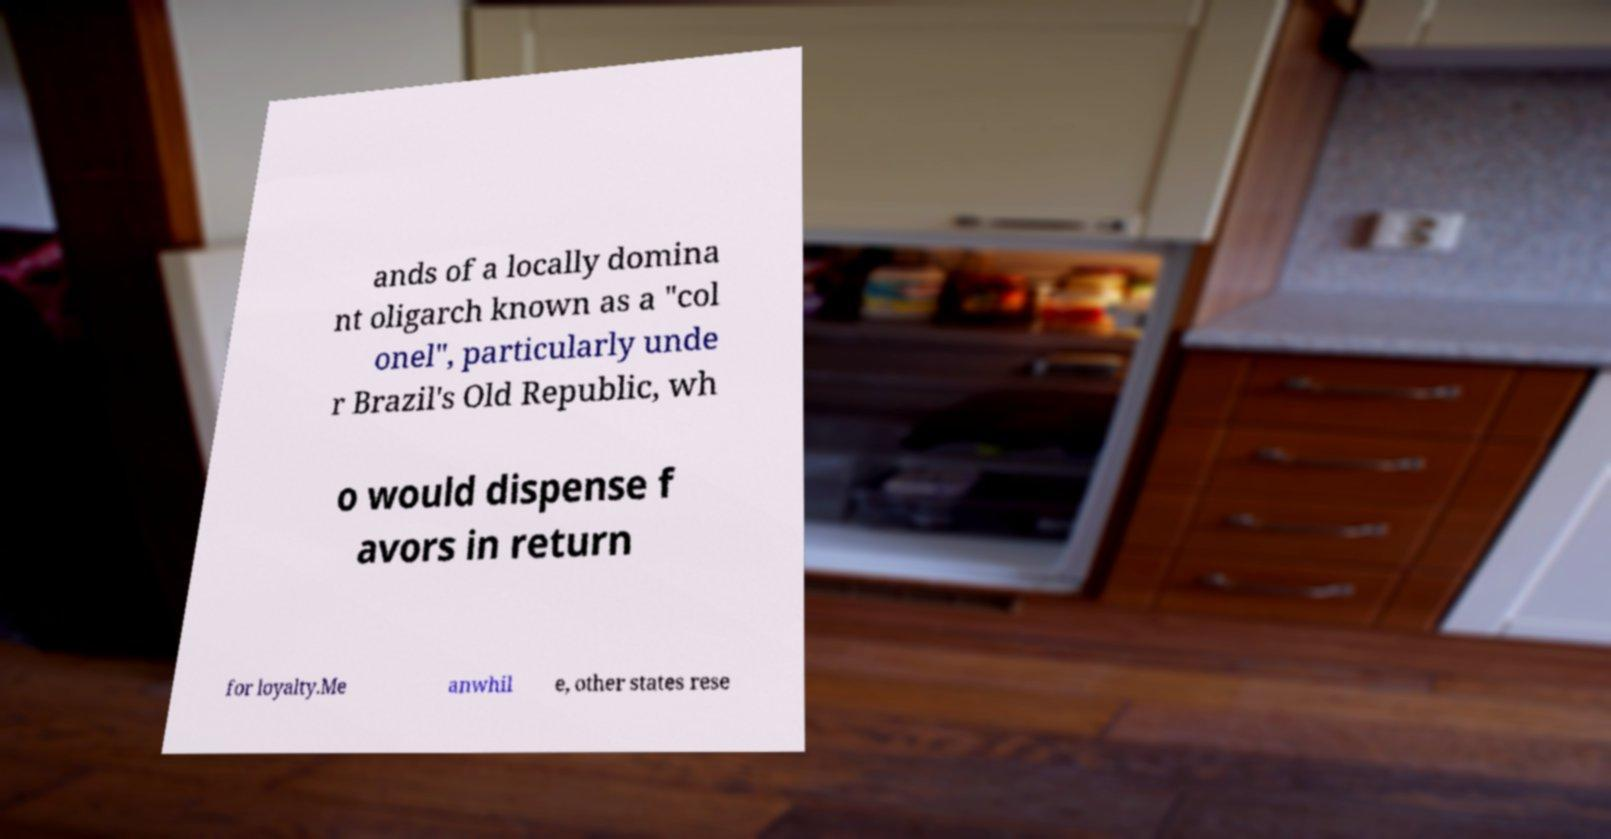Please identify and transcribe the text found in this image. ands of a locally domina nt oligarch known as a "col onel", particularly unde r Brazil's Old Republic, wh o would dispense f avors in return for loyalty.Me anwhil e, other states rese 